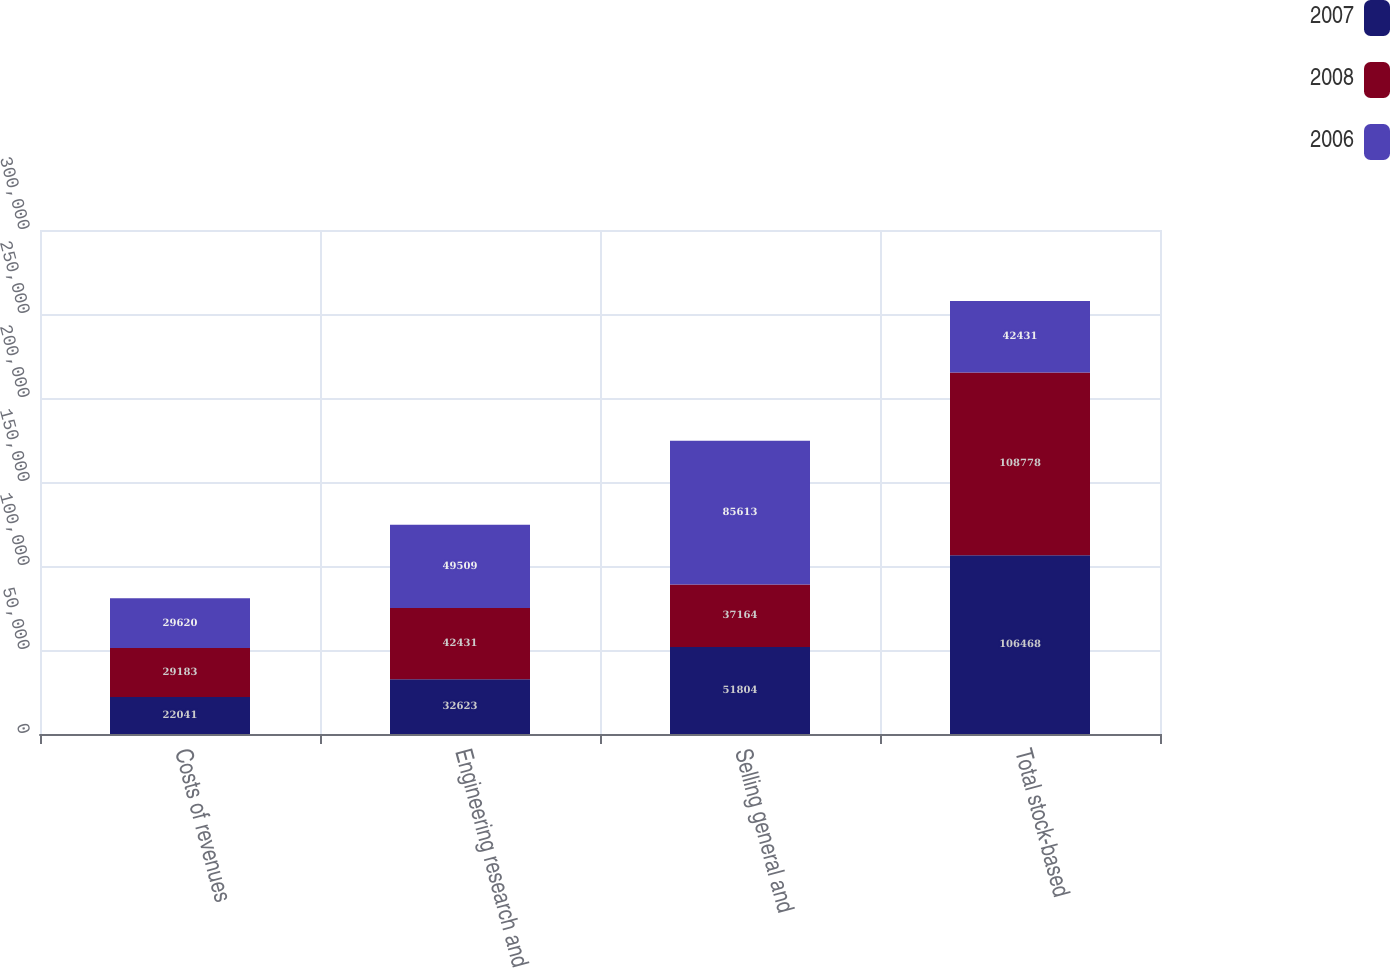<chart> <loc_0><loc_0><loc_500><loc_500><stacked_bar_chart><ecel><fcel>Costs of revenues<fcel>Engineering research and<fcel>Selling general and<fcel>Total stock-based<nl><fcel>2007<fcel>22041<fcel>32623<fcel>51804<fcel>106468<nl><fcel>2008<fcel>29183<fcel>42431<fcel>37164<fcel>108778<nl><fcel>2006<fcel>29620<fcel>49509<fcel>85613<fcel>42431<nl></chart> 